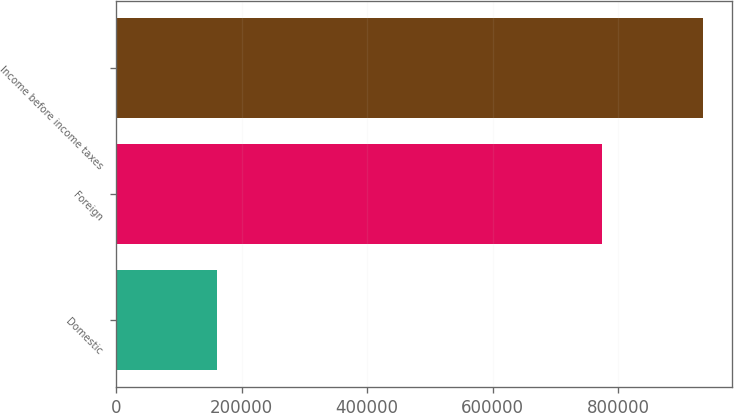<chart> <loc_0><loc_0><loc_500><loc_500><bar_chart><fcel>Domestic<fcel>Foreign<fcel>Income before income taxes<nl><fcel>161248<fcel>773499<fcel>934747<nl></chart> 